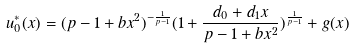Convert formula to latex. <formula><loc_0><loc_0><loc_500><loc_500>u _ { 0 } ^ { * } ( x ) = ( p - 1 + b x ^ { 2 } ) ^ { - \frac { 1 } { p - 1 } } ( 1 + \frac { d _ { 0 } + d _ { 1 } x } { p - 1 + b x ^ { 2 } } ) ^ { \frac { 1 } { p - 1 } } + g ( x )</formula> 